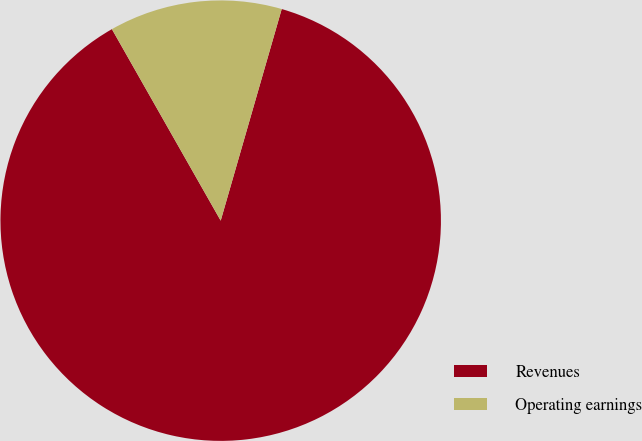Convert chart to OTSL. <chart><loc_0><loc_0><loc_500><loc_500><pie_chart><fcel>Revenues<fcel>Operating earnings<nl><fcel>87.31%<fcel>12.69%<nl></chart> 